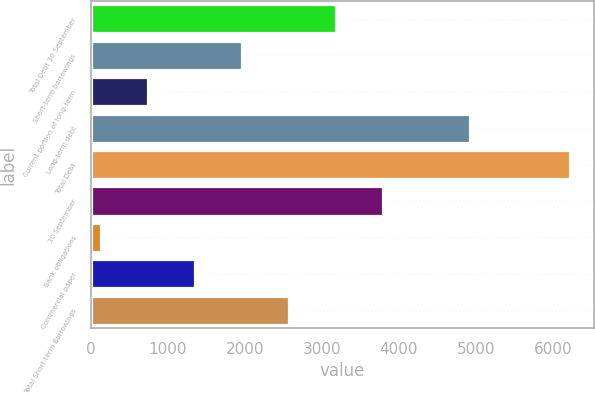<chart> <loc_0><loc_0><loc_500><loc_500><bar_chart><fcel>Total Debt 30 September<fcel>Short-term borrowings<fcel>Current portion of long-term<fcel>Long-term debt<fcel>Total Debt<fcel>30 September<fcel>Bank obligations<fcel>Commercial paper<fcel>Total Short-term Borrowings<nl><fcel>3179.15<fcel>1960.73<fcel>742.31<fcel>4918.1<fcel>6225.2<fcel>3788.36<fcel>133.1<fcel>1351.52<fcel>2569.94<nl></chart> 